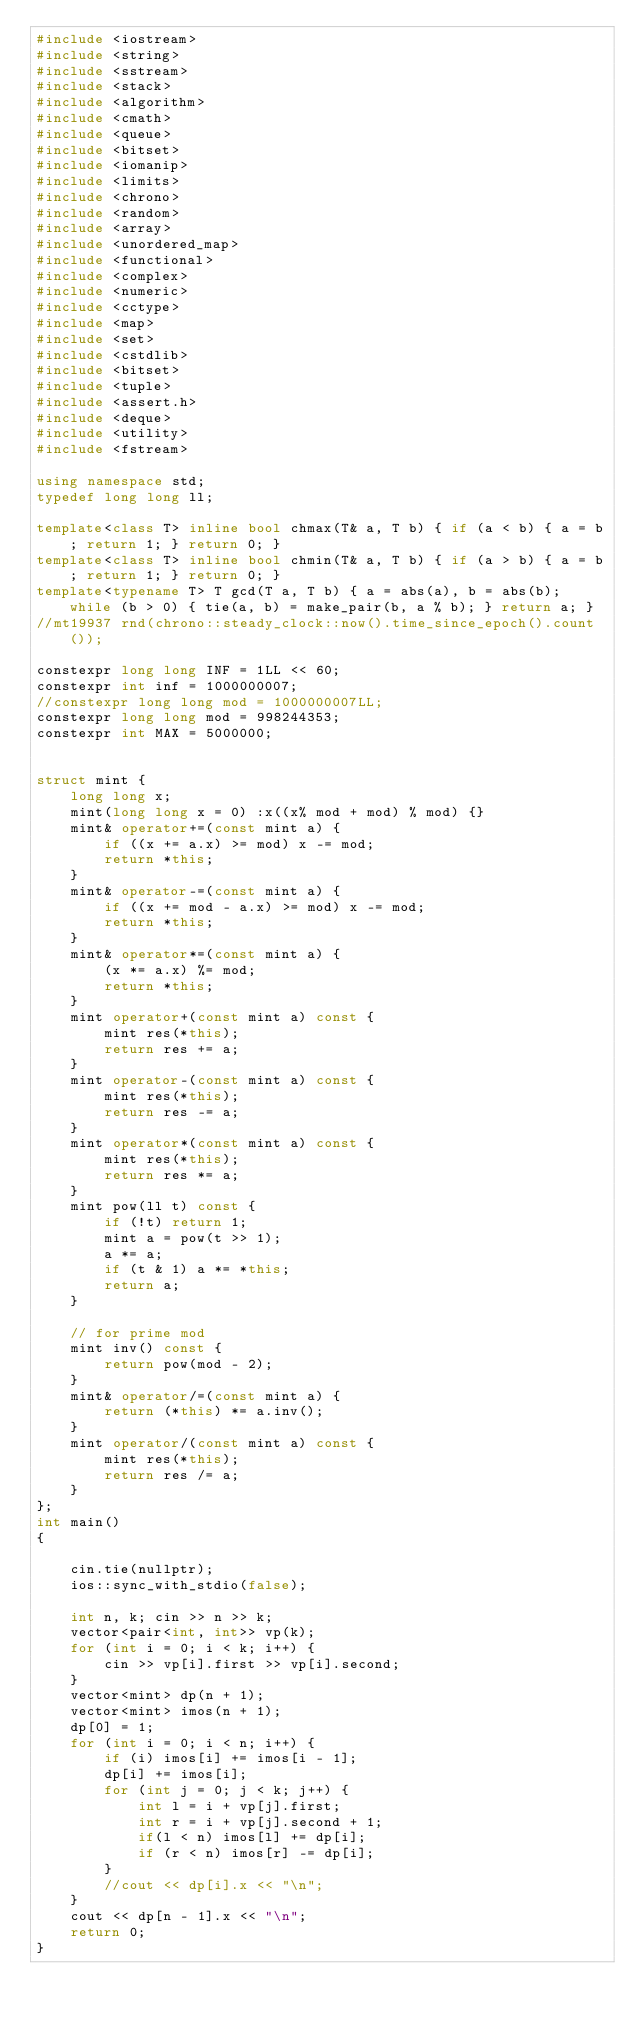<code> <loc_0><loc_0><loc_500><loc_500><_C++_>#include <iostream>
#include <string>
#include <sstream>
#include <stack>
#include <algorithm>
#include <cmath>
#include <queue>
#include <bitset>
#include <iomanip>
#include <limits>
#include <chrono>
#include <random>
#include <array>
#include <unordered_map>
#include <functional>
#include <complex>
#include <numeric>
#include <cctype>
#include <map>
#include <set>
#include <cstdlib>
#include <bitset>
#include <tuple>
#include <assert.h>
#include <deque>
#include <utility>
#include <fstream>

using namespace std;
typedef long long ll;

template<class T> inline bool chmax(T& a, T b) { if (a < b) { a = b; return 1; } return 0; }
template<class T> inline bool chmin(T& a, T b) { if (a > b) { a = b; return 1; } return 0; }
template<typename T> T gcd(T a, T b) { a = abs(a), b = abs(b); while (b > 0) { tie(a, b) = make_pair(b, a % b); } return a; }
//mt19937 rnd(chrono::steady_clock::now().time_since_epoch().count());

constexpr long long INF = 1LL << 60;
constexpr int inf = 1000000007;
//constexpr long long mod = 1000000007LL;
constexpr long long mod = 998244353;
constexpr int MAX = 5000000;


struct mint {
	long long x;
	mint(long long x = 0) :x((x% mod + mod) % mod) {}
	mint& operator+=(const mint a) {
		if ((x += a.x) >= mod) x -= mod;
		return *this;
	}
	mint& operator-=(const mint a) {
		if ((x += mod - a.x) >= mod) x -= mod;
		return *this;
	}
	mint& operator*=(const mint a) {
		(x *= a.x) %= mod;
		return *this;
	}
	mint operator+(const mint a) const {
		mint res(*this);
		return res += a;
	}
	mint operator-(const mint a) const {
		mint res(*this);
		return res -= a;
	}
	mint operator*(const mint a) const {
		mint res(*this);
		return res *= a;
	}
	mint pow(ll t) const {
		if (!t) return 1;
		mint a = pow(t >> 1);
		a *= a;
		if (t & 1) a *= *this;
		return a;
	}

	// for prime mod
	mint inv() const {
		return pow(mod - 2);
	}
	mint& operator/=(const mint a) {
		return (*this) *= a.inv();
	}
	mint operator/(const mint a) const {
		mint res(*this);
		return res /= a;
	}
};
int main()
{

	cin.tie(nullptr);
	ios::sync_with_stdio(false);

	int n, k; cin >> n >> k;
	vector<pair<int, int>> vp(k);
	for (int i = 0; i < k; i++) {
		cin >> vp[i].first >> vp[i].second;
	}
	vector<mint> dp(n + 1);
	vector<mint> imos(n + 1);
	dp[0] = 1;
	for (int i = 0; i < n; i++) {
		if (i) imos[i] += imos[i - 1];
		dp[i] += imos[i];
		for (int j = 0; j < k; j++) {
			int l = i + vp[j].first;
			int r = i + vp[j].second + 1;
			if(l < n) imos[l] += dp[i];
			if (r < n) imos[r] -= dp[i];
		}
		//cout << dp[i].x << "\n";
	}
	cout << dp[n - 1].x << "\n";
	return 0;
}
</code> 